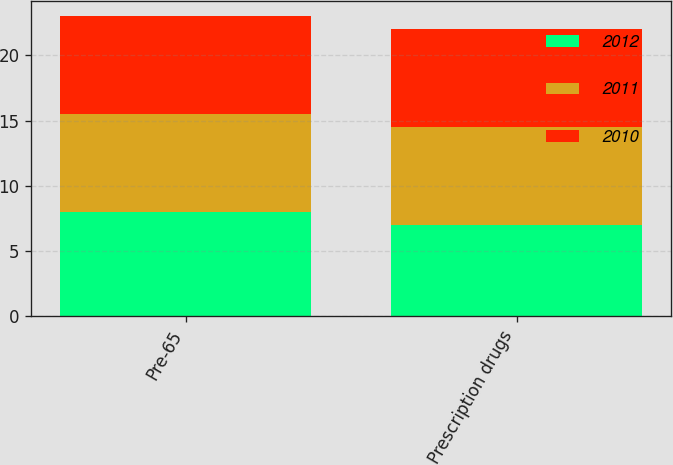Convert chart. <chart><loc_0><loc_0><loc_500><loc_500><stacked_bar_chart><ecel><fcel>Pre-65<fcel>Prescription drugs<nl><fcel>2012<fcel>8<fcel>7<nl><fcel>2011<fcel>7.5<fcel>7.5<nl><fcel>2010<fcel>7.5<fcel>7.5<nl></chart> 